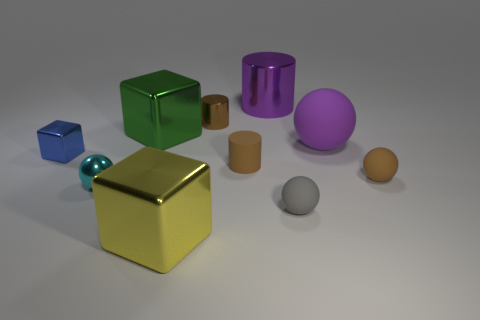Subtract all balls. How many objects are left? 6 Subtract all small brown matte balls. Subtract all purple matte objects. How many objects are left? 8 Add 9 tiny brown balls. How many tiny brown balls are left? 10 Add 5 tiny brown cylinders. How many tiny brown cylinders exist? 7 Subtract 0 green spheres. How many objects are left? 10 